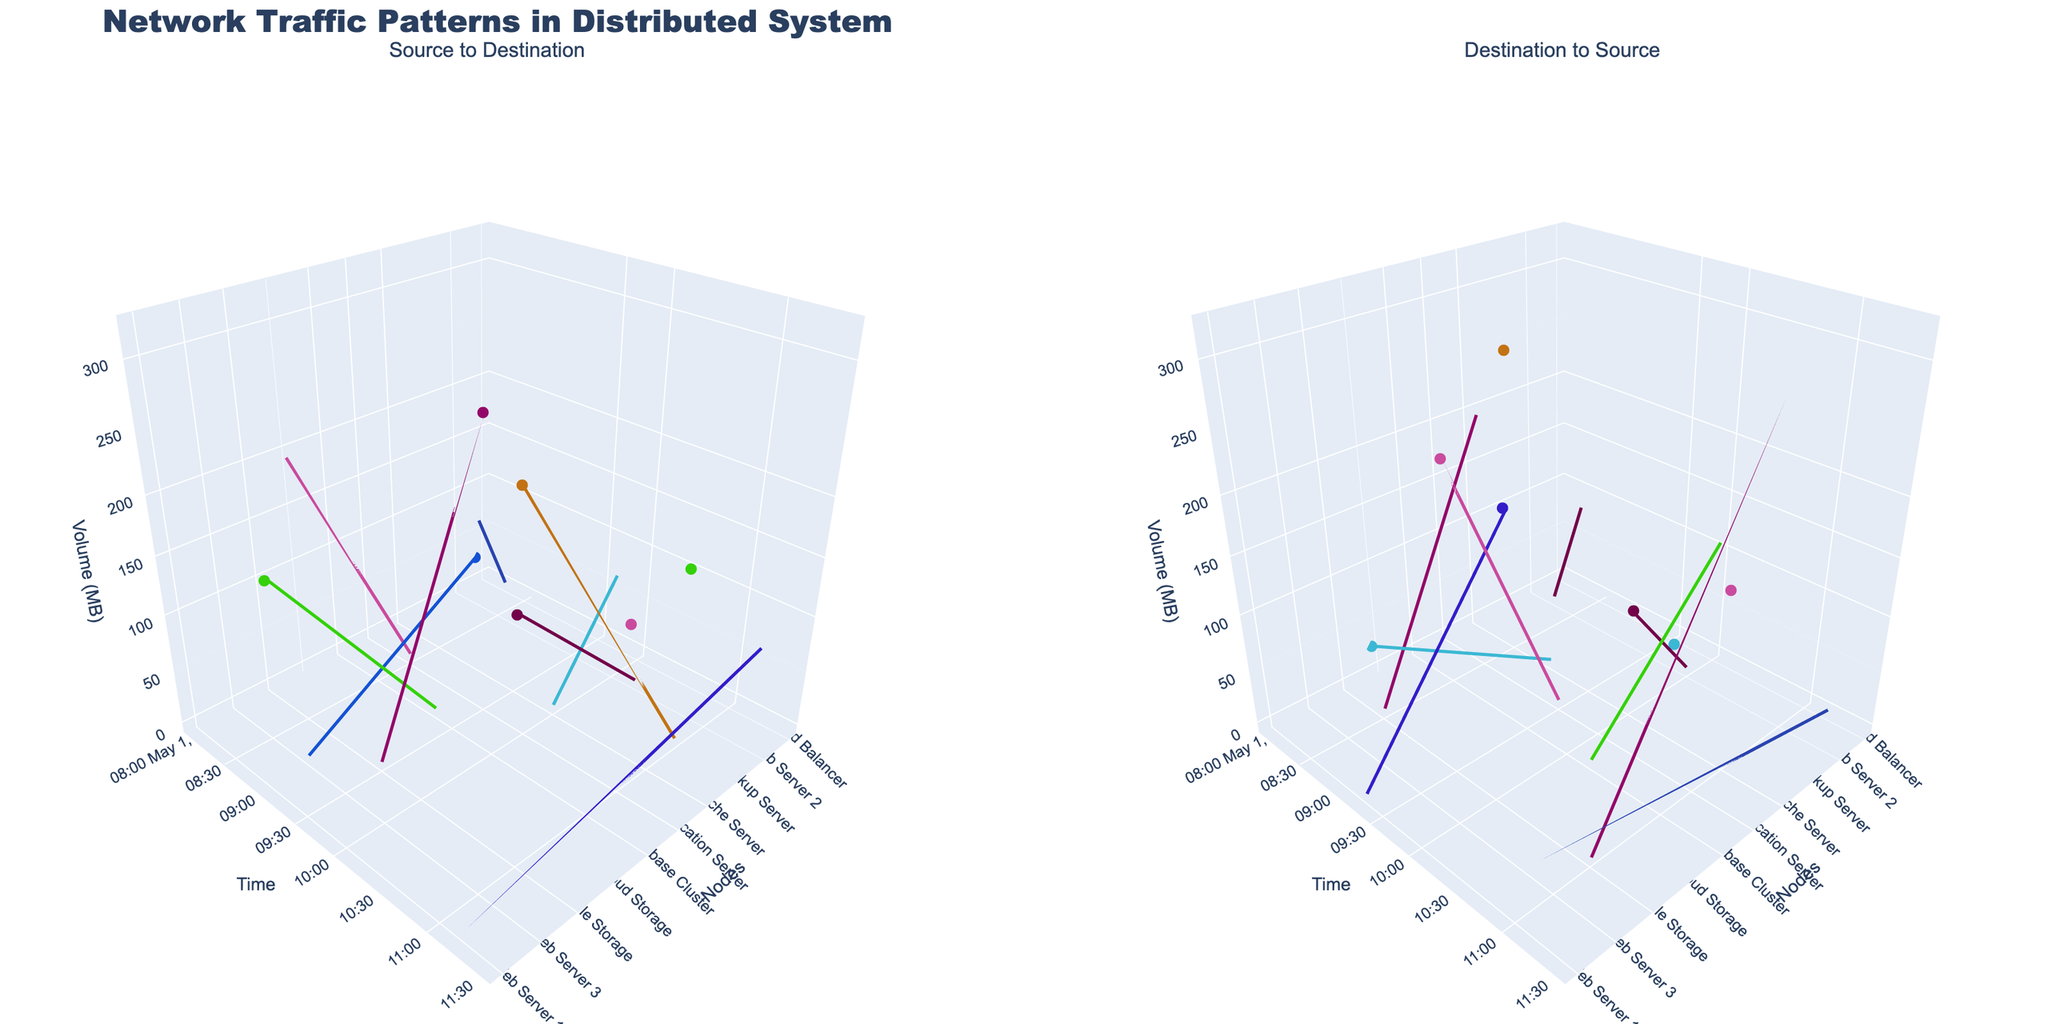How many nodes are represented in the figure? To find the number of nodes represented, count the unique nodes listed on the x-axis or in the legend. Based on the figure, there are 'Web Server 1', 'Database Cluster', 'Load Balancer', 'Web Server 2', 'Application Server', 'File Storage', 'Backup Server', 'Cloud Storage', 'Web Server 3', and 'Cache Server'.
Answer: 10 Which node appears most frequently as a destination? Observe the destination nodes in the "Destination to Source" subplot. Count the number of times each node appears as a destination. The 'Database Cluster' is used as a destination node three times (from 'Web Server 1', 'Web Server 2', 'Load Balancer').
Answer: Database Cluster At what time does the highest volume transfer occur, and which nodes are involved? Locate the highest point on the z-axis in the "Source to Destination" subplot. This corresponds to the 'Backup Server' sending 320 MB to 'Cloud Storage' at timestamp 2023-05-01 09:45:00.
Answer: 2023-05-01 09:45:00; Backup Server to Cloud Storage What is the cumulative data volume transfer from the Backup Server? Add up all the volume values for the Backup Server as the source node: 300 MB (to Cloud Storage) + 280 MB (to File Storage). This sums up to 580 MB.
Answer: 580 MB How does the data volume from Web Server 1 to Database Cluster compare to the reverse? Compare the volumes in "Source to Destination" for 'Web Server 1' to 'Database Cluster' and vice versa in "Destination to Source". Web Server 1 to Database Cluster is 150 MB, while Database Cluster to Web Server 1 is 180 MB.
Answer: Less; 150 MB vs 180 MB Which node has the earliest recorded data transfer? Look at the points closest to the origin on the y-axis (timestamp) in the "Source to Destination" subplot. The earliest timestamp is 2023-05-01 08:00:00 involving 'Web Server 1' to 'Database Cluster'.
Answer: Web Server 1 Which transfer involves the smallest volume and when does it occur? Identify the lowest point on the z-axis in either subplot. The smallest volume transfer is 60 MB from 'Web Server 1' to 'Load Balancer' at 2023-05-01 11:15:00.
Answer: 60 MB; 2023-05-01 11:15:00 Which transfer direction involves 'Application Server' the most by frequency? Count the number of times 'Application Server' appears in both "Source to Destination" and "Destination to Source" subplots. 'Application Server' appears more frequently as a destination (from 'File Storage' and 'Database Cluster', twice) compared to as a source (to 'File Storage' and 'Cache Server', twice). However, in an equal scenario (two times each), we mention them to show parity.
Answer: Equal 